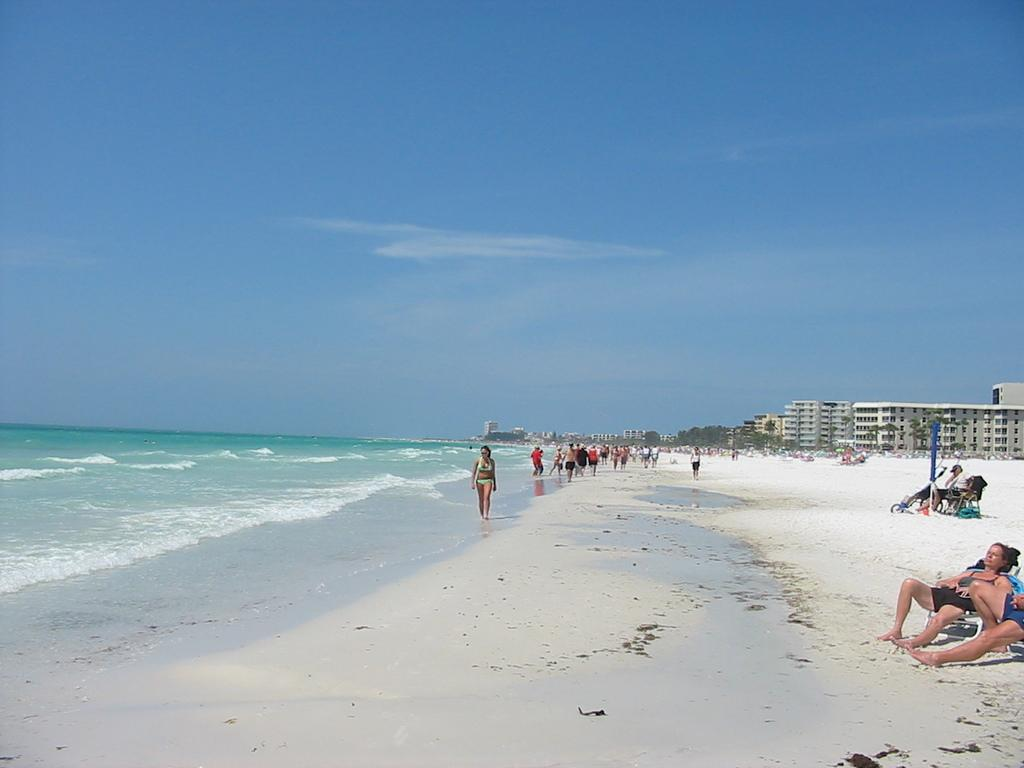What are the people in the image doing? There are people sitting on chairs and walking on sand in the image. What can be seen in the background of the image? There are buildings, trees, and the sky visible in the background of the image. What is the primary surface that the people walking on are in contact with? The people walking on sand are in contact with sand. What else is present in the image besides people and the background? There are objects present in the image. What type of dirt can be seen covering the structure in the image? There is no structure or dirt present in the image. 